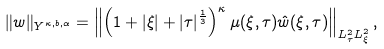Convert formula to latex. <formula><loc_0><loc_0><loc_500><loc_500>\| w \| _ { Y ^ { \kappa , b , \alpha } } = \left \| \left ( 1 + | \xi | + | \tau | ^ { \frac { 1 } { 3 } } \right ) ^ { \kappa } \mu ( \xi , \tau ) \hat { w } ( \xi , \tau ) \right \| _ { L _ { \tau } ^ { 2 } L ^ { 2 } _ { \xi } } ,</formula> 